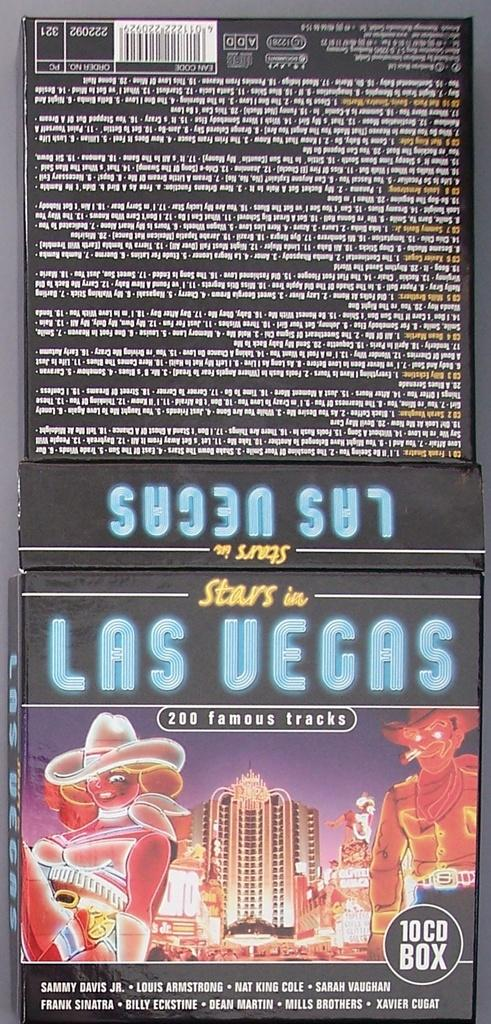<image>
Offer a succinct explanation of the picture presented. The 10 cd box contains many favourite songs from Las Vegas. 